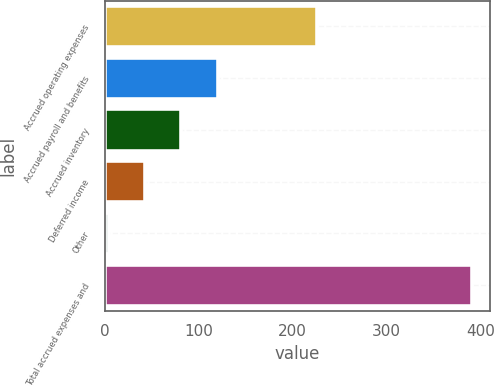<chart> <loc_0><loc_0><loc_500><loc_500><bar_chart><fcel>Accrued operating expenses<fcel>Accrued payroll and benefits<fcel>Accrued inventory<fcel>Deferred income<fcel>Other<fcel>Total accrued expenses and<nl><fcel>226.2<fcel>120.31<fcel>81.64<fcel>42.97<fcel>4.3<fcel>391<nl></chart> 